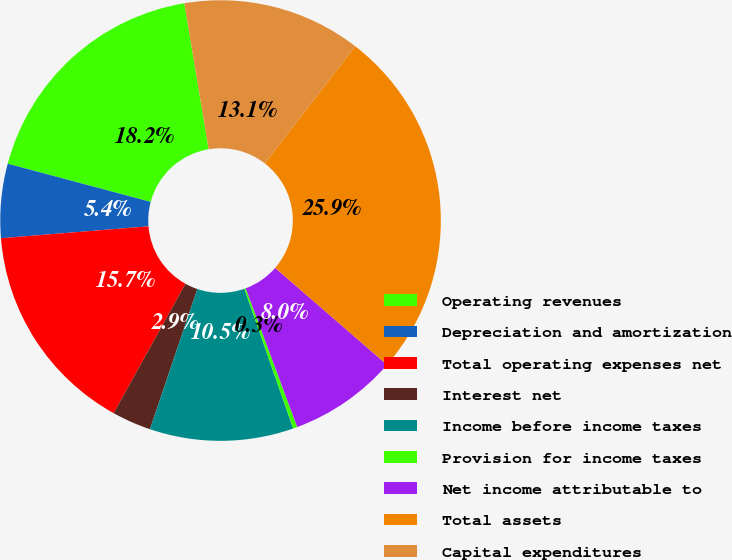Convert chart. <chart><loc_0><loc_0><loc_500><loc_500><pie_chart><fcel>Operating revenues<fcel>Depreciation and amortization<fcel>Total operating expenses net<fcel>Interest net<fcel>Income before income taxes<fcel>Provision for income taxes<fcel>Net income attributable to<fcel>Total assets<fcel>Capital expenditures<nl><fcel>18.22%<fcel>5.43%<fcel>15.66%<fcel>2.87%<fcel>10.54%<fcel>0.31%<fcel>7.98%<fcel>25.89%<fcel>13.1%<nl></chart> 